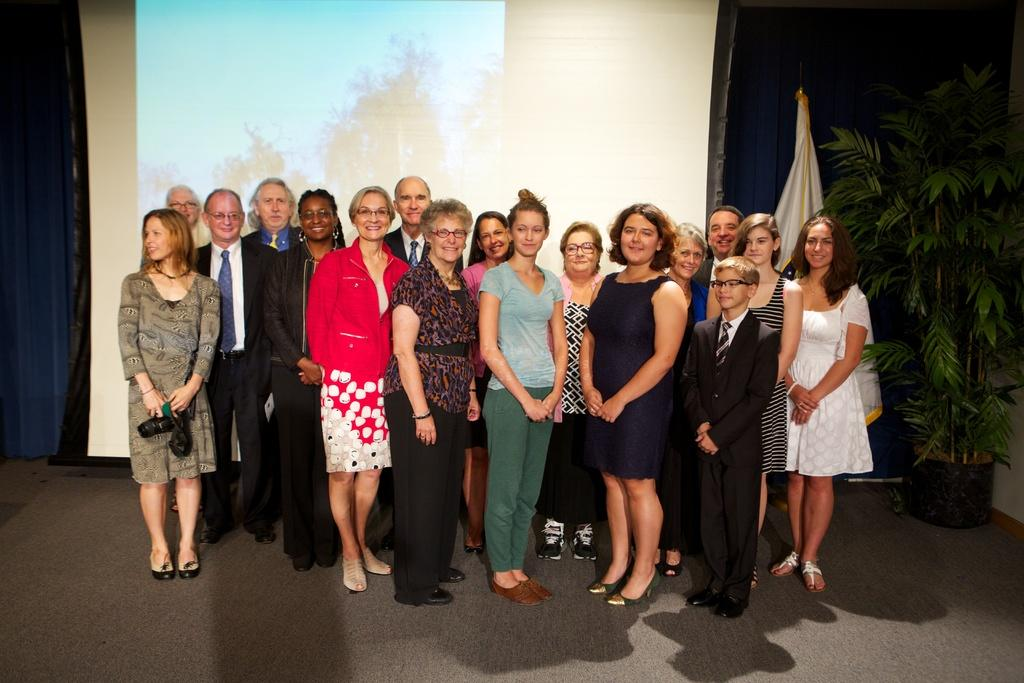How many people are in the image? There is a group of people in the image. What can be observed about the clothing of the people in the image? The people are wearing different color dresses. What can be seen in the background of the image? There is a flower pot, a blue curtain, and a projector screen visible in the background. What type of knife is being used for educational purposes in the image? There is no knife present in the image, and no educational activities are depicted. 